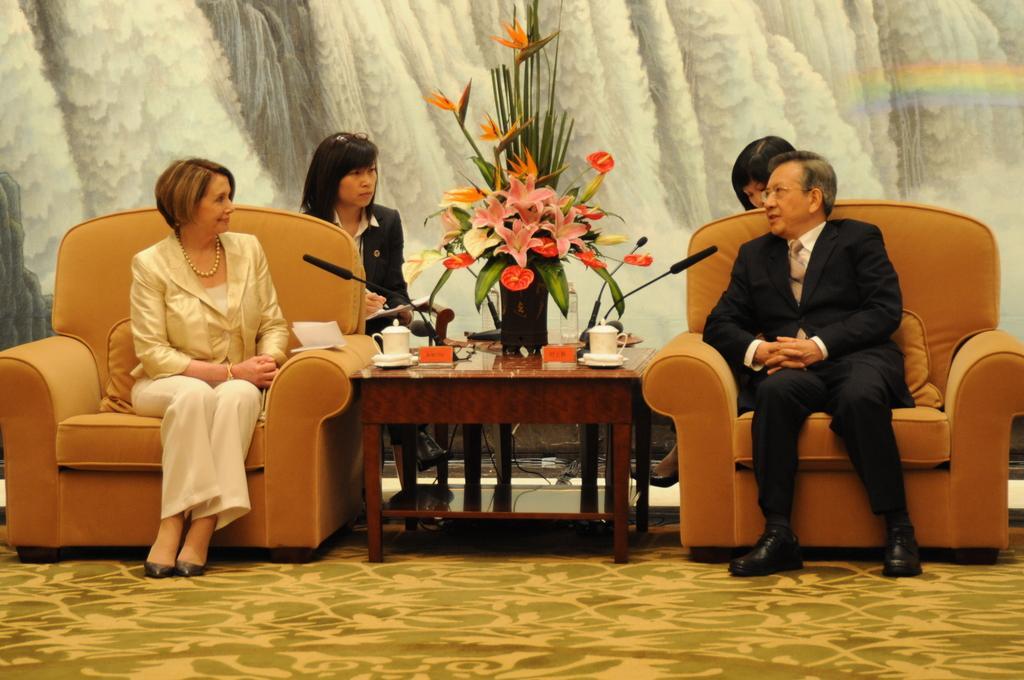Describe this image in one or two sentences. In this image i can see a woman and a man sitting on a couches. I can see a table in between them and on a table there are two cups, a flower bouquet and microphones. In the background i can see 2 persons sitting behind them and a scenery of water fall. 